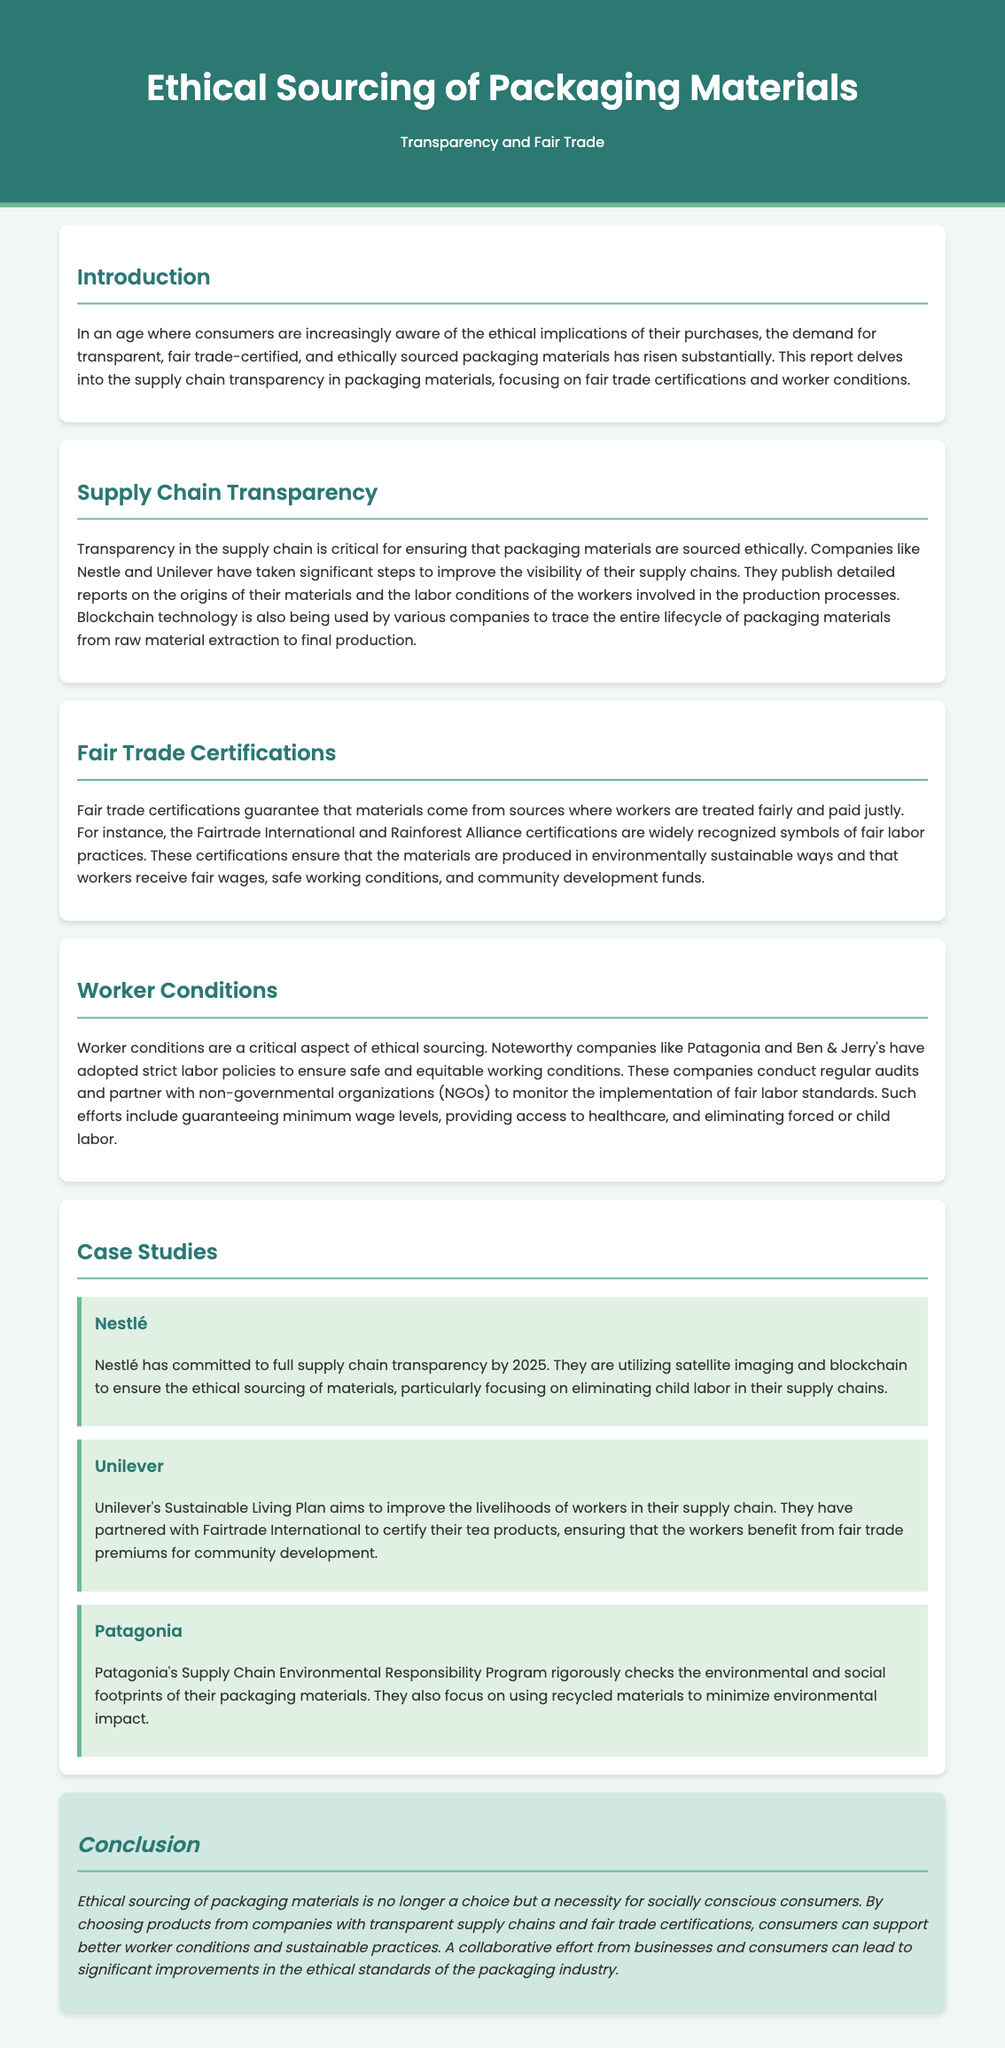What is the title of the report? The title is prominently displayed in the header of the document, indicating the focus of the content.
Answer: Ethical Sourcing of Packaging Materials What organizations are mentioned as examples of companies improving supply chain transparency? The document lists these companies as part of the discussion on supply chain transparency, highlighting their efforts.
Answer: Nestle and Unilever Which certifications are recognized for fair trade practices? The report specifies these certifications as widely recognized symbols in the fair trade movement.
Answer: Fairtrade International and Rainforest Alliance What year has Nestlé committed to achieve full supply chain transparency? This timeframe is outlined in the case study section, indicating Nestlé's goals.
Answer: 2025 What is the main goal of Unilever's Sustainable Living Plan? The document elaborates on this goal within the context of improving worker conditions in the supply chain.
Answer: Improve the livelihoods of workers Which company is noted for using satellite imaging and blockchain technology? The case study provides this information about the company's approach to sourcing materials ethically.
Answer: Nestlé What are Patagonia's efforts regarding environmental responsibility? The report states Patagonia's initiatives related to their environmental impact and the materials used in their packaging.
Answer: Supply Chain Environmental Responsibility Program What is the concluding message about ethical sourcing? The conclusion summarizes the urgent message conveyed about consumers and companies in the ethical sourcing context.
Answer: A necessity for socially conscious consumers 